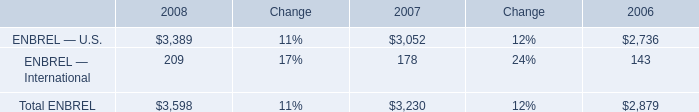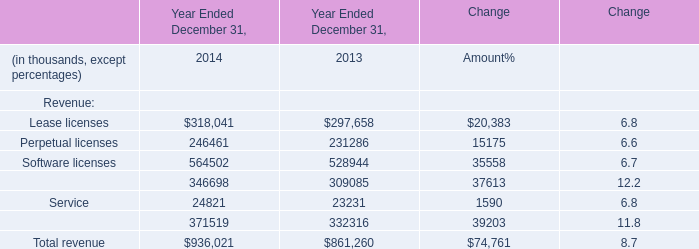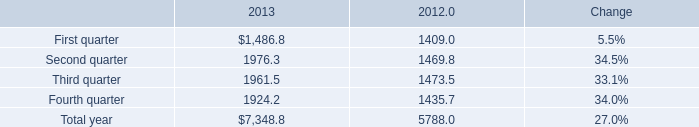What's the average of Service and Maintenance in 2014? (in thousand) 
Computations: ((24821 + 346698) / 2)
Answer: 185759.5. 